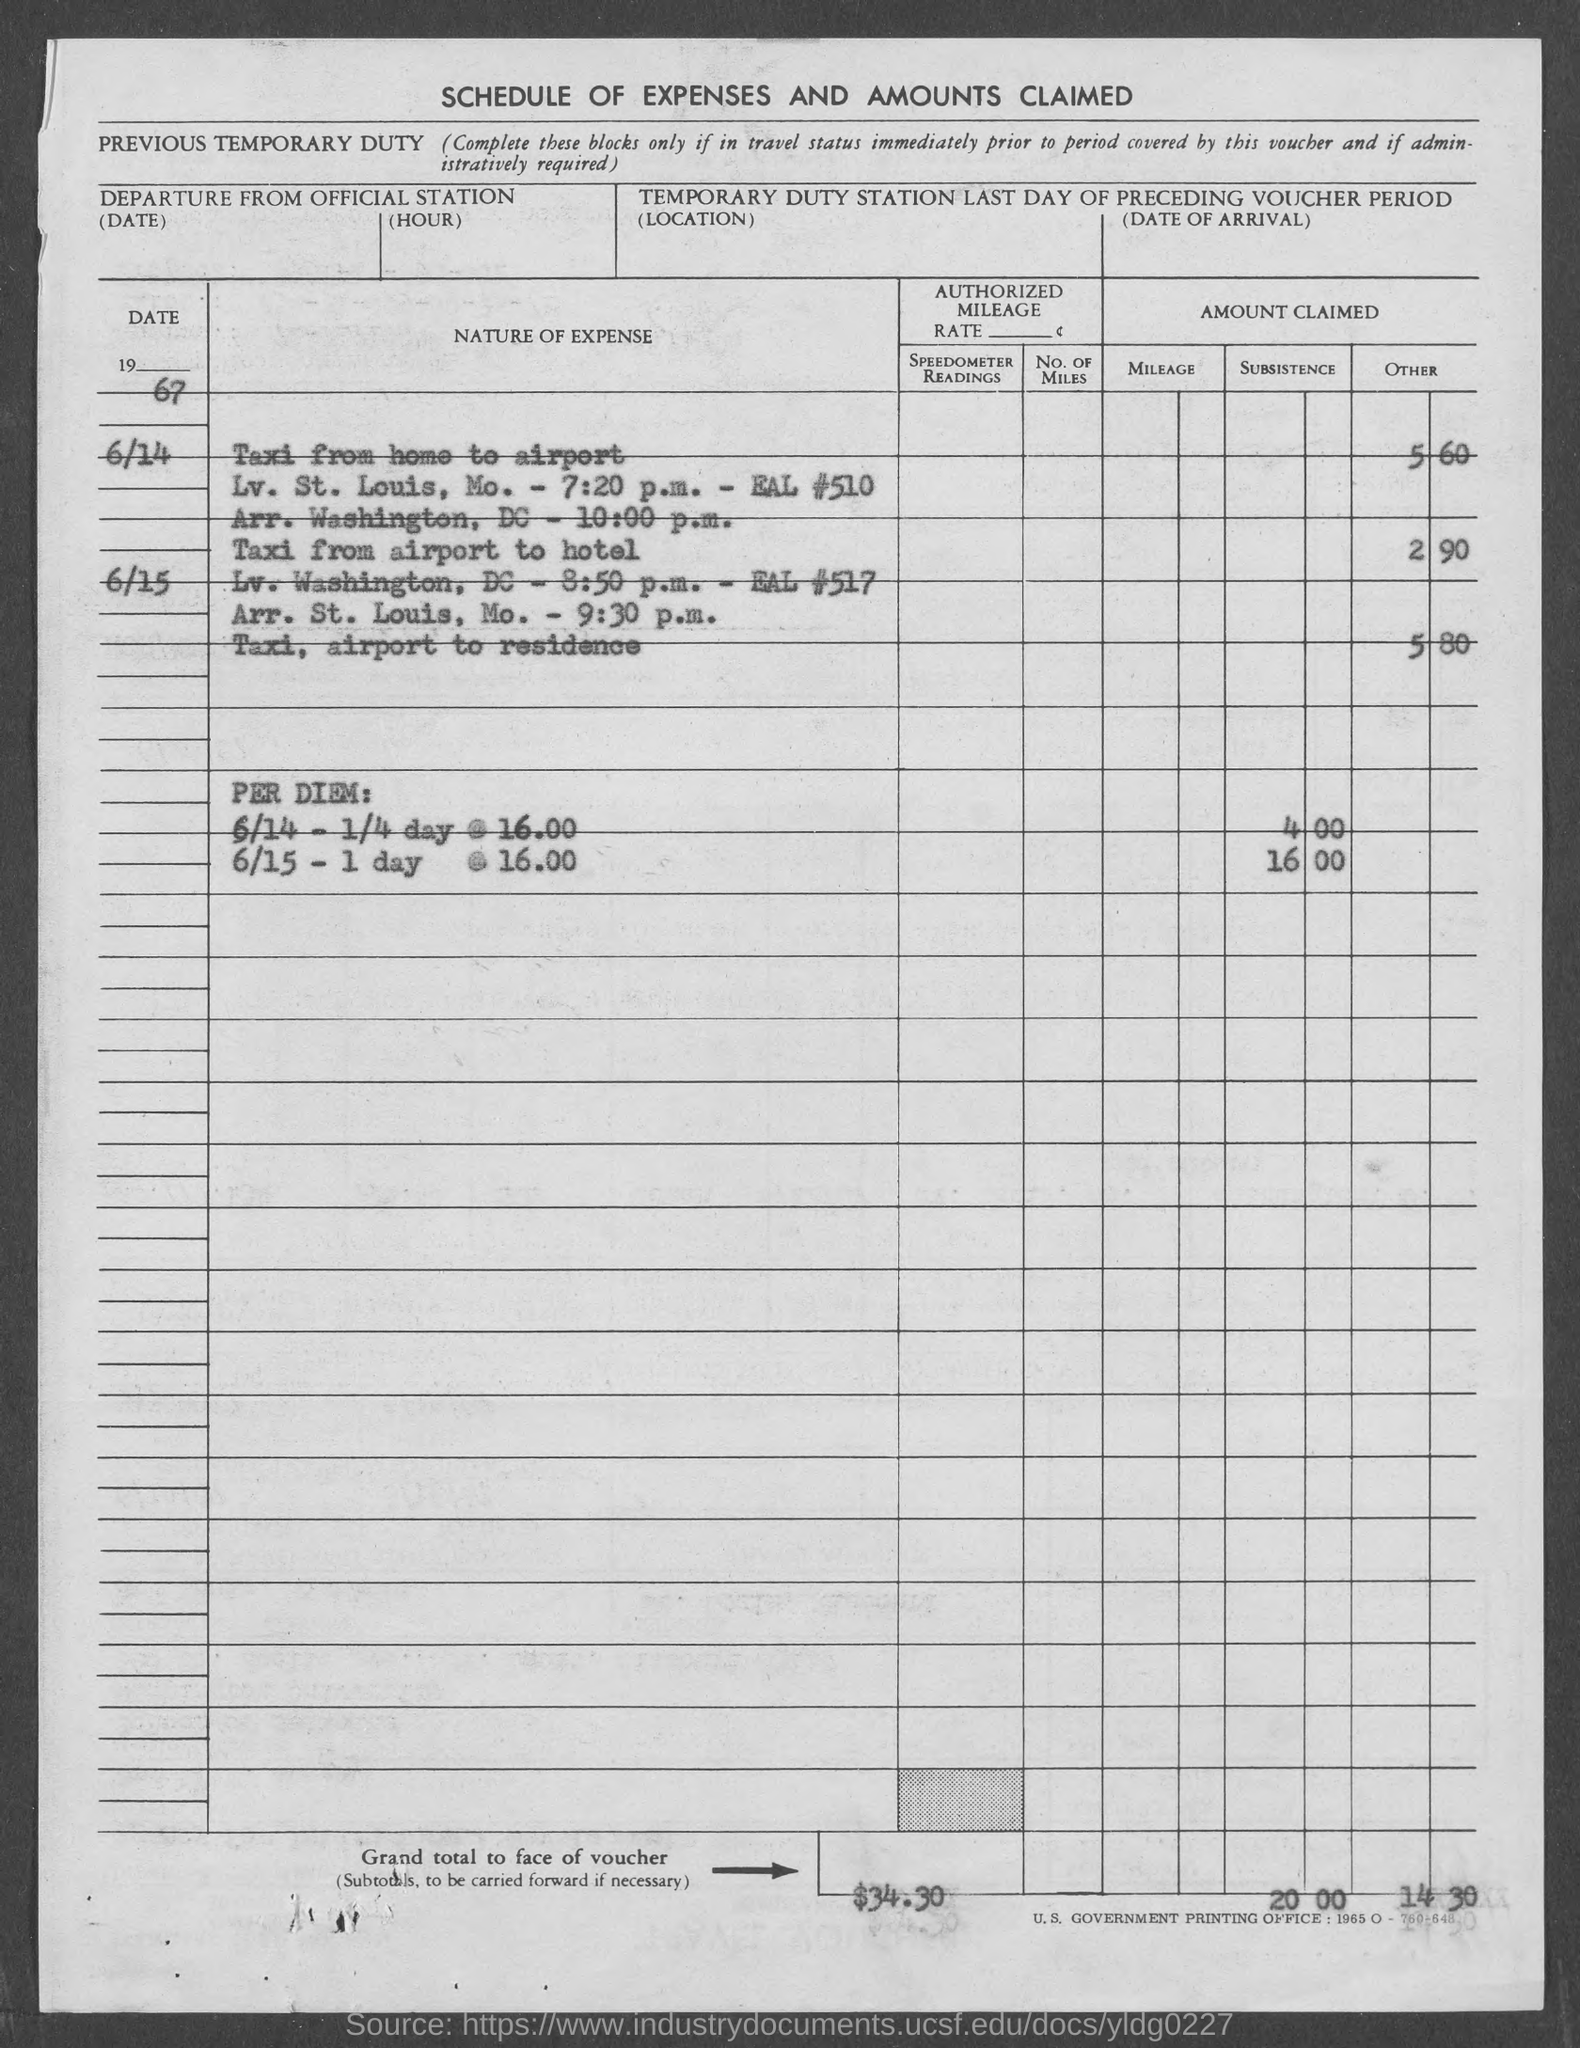List a handful of essential elements in this visual. The grand total in the voucher is $34.30. 